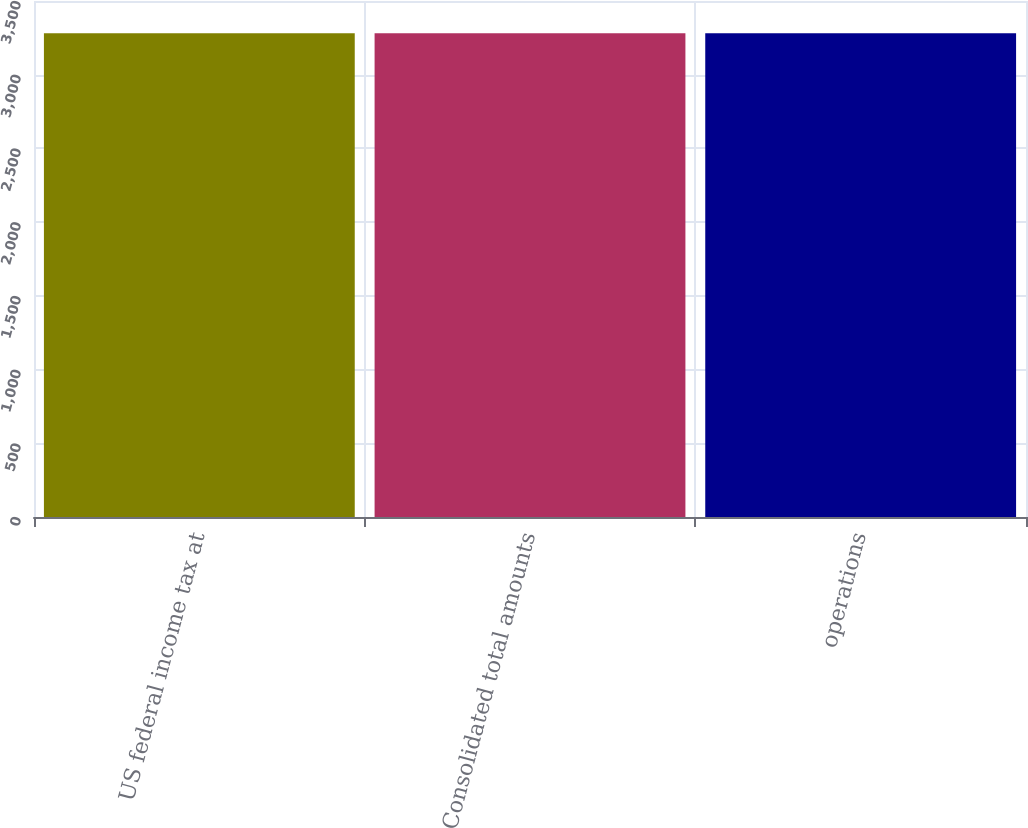<chart> <loc_0><loc_0><loc_500><loc_500><bar_chart><fcel>US federal income tax at<fcel>Consolidated total amounts<fcel>operations<nl><fcel>3281<fcel>3281.1<fcel>3281.2<nl></chart> 